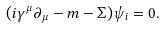<formula> <loc_0><loc_0><loc_500><loc_500>( i \gamma ^ { \mu } \partial _ { \mu } - m - \Sigma ) \psi _ { i } = 0 .</formula> 